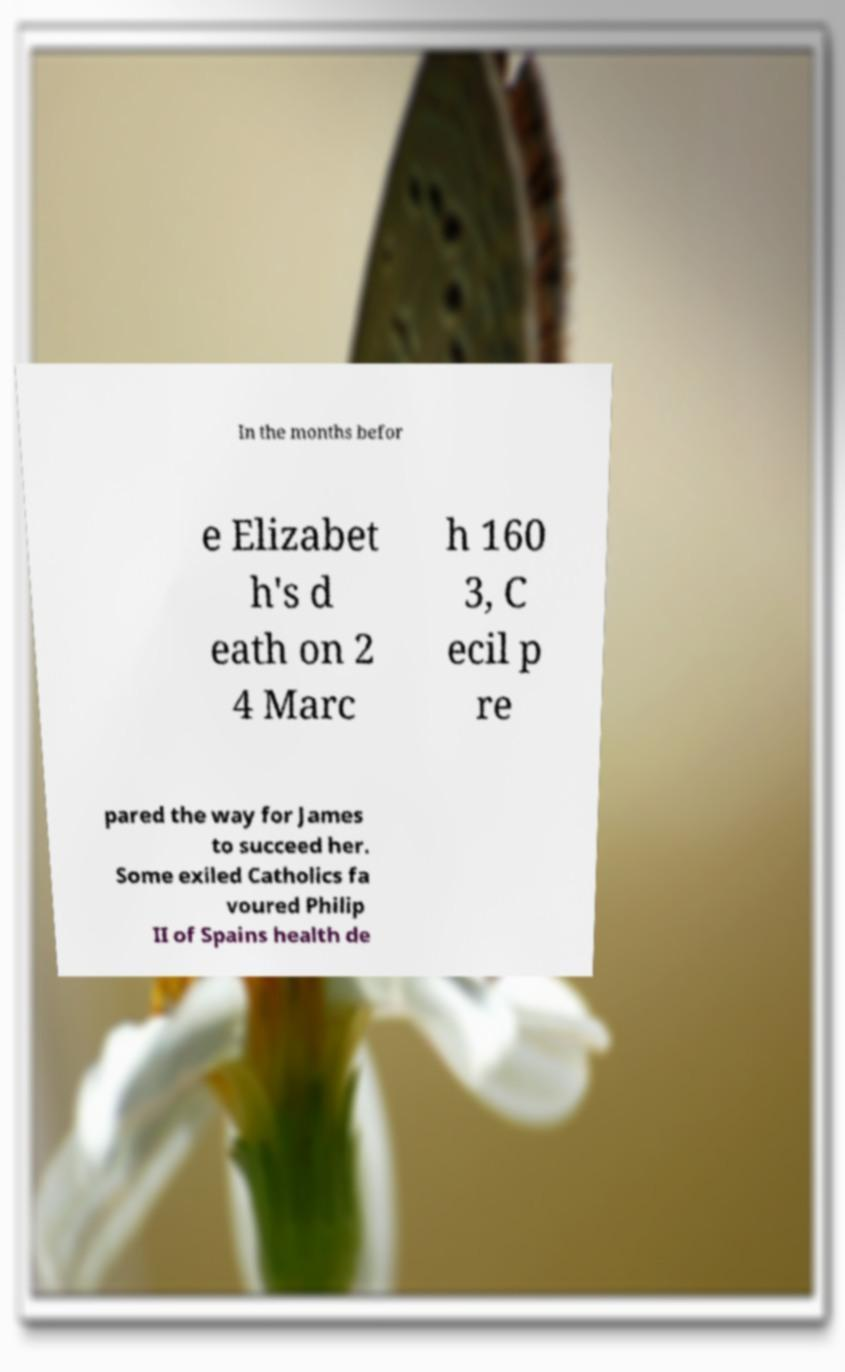Please identify and transcribe the text found in this image. In the months befor e Elizabet h's d eath on 2 4 Marc h 160 3, C ecil p re pared the way for James to succeed her. Some exiled Catholics fa voured Philip II of Spains health de 